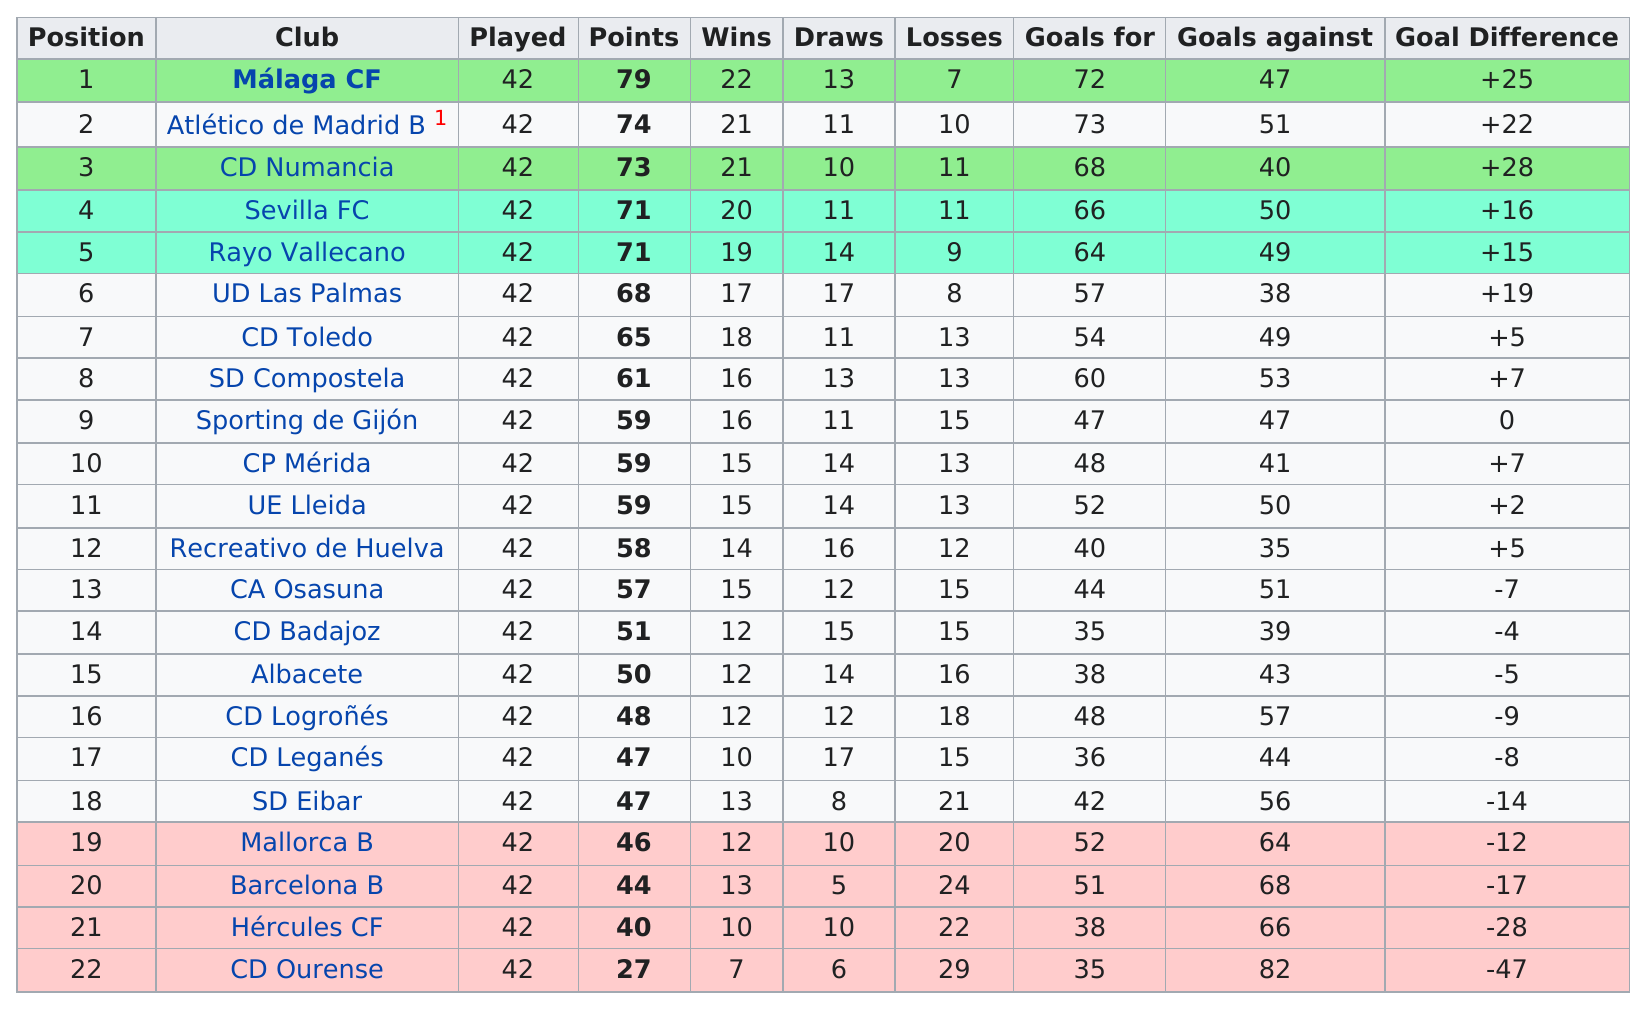Draw attention to some important aspects in this diagram. The total number of positions listed is 22. Five clubs scored at least 70 points or more. In the total number of goals scored between Ue Lleida and Ud Las Palmas, there were 109 goals. Eight teams have earned at least 60 points. There are a total of 22 teams. 